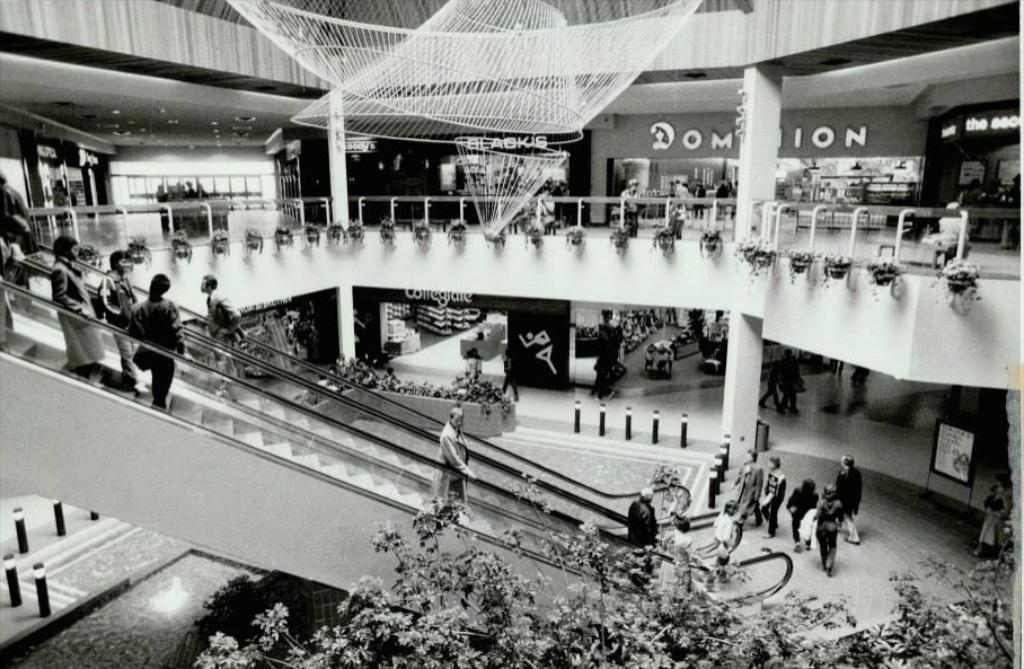Please provide a concise description of this image. At the bottom of the image there are some plants. In the middle of the image there is a escalator and few people are standing. In the middle of the image there is fencing and there are some plants. Behind the fencing there are some stores. 